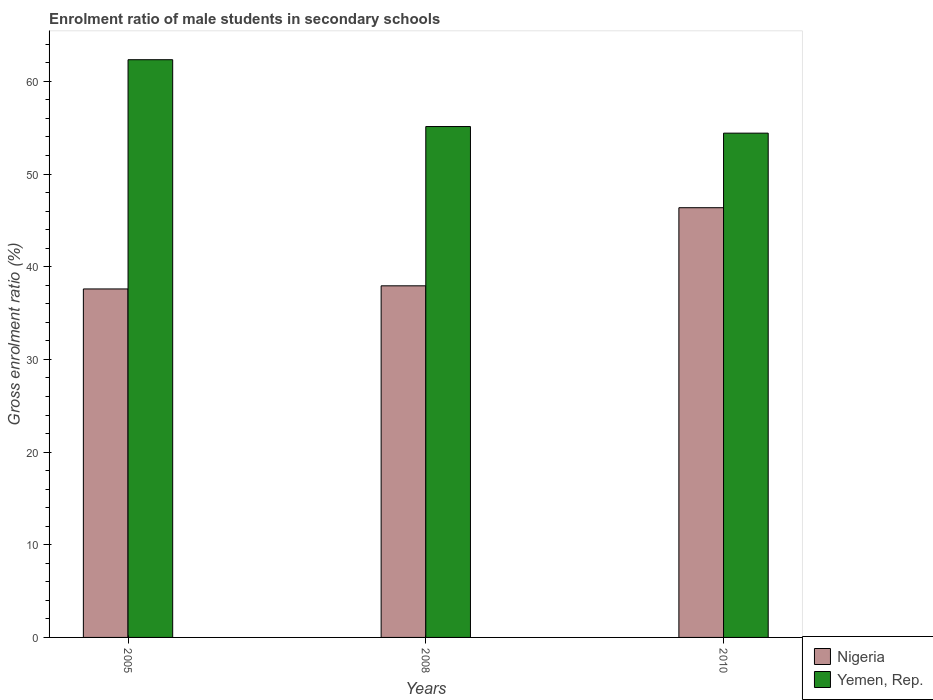How many groups of bars are there?
Provide a short and direct response. 3. Are the number of bars per tick equal to the number of legend labels?
Make the answer very short. Yes. What is the enrolment ratio of male students in secondary schools in Yemen, Rep. in 2008?
Your answer should be compact. 55.13. Across all years, what is the maximum enrolment ratio of male students in secondary schools in Yemen, Rep.?
Make the answer very short. 62.34. Across all years, what is the minimum enrolment ratio of male students in secondary schools in Nigeria?
Provide a succinct answer. 37.6. What is the total enrolment ratio of male students in secondary schools in Nigeria in the graph?
Your answer should be compact. 121.91. What is the difference between the enrolment ratio of male students in secondary schools in Yemen, Rep. in 2008 and that in 2010?
Provide a succinct answer. 0.71. What is the difference between the enrolment ratio of male students in secondary schools in Nigeria in 2008 and the enrolment ratio of male students in secondary schools in Yemen, Rep. in 2010?
Your answer should be compact. -16.47. What is the average enrolment ratio of male students in secondary schools in Nigeria per year?
Your answer should be compact. 40.64. In the year 2010, what is the difference between the enrolment ratio of male students in secondary schools in Yemen, Rep. and enrolment ratio of male students in secondary schools in Nigeria?
Your response must be concise. 8.05. In how many years, is the enrolment ratio of male students in secondary schools in Nigeria greater than 22 %?
Your answer should be compact. 3. What is the ratio of the enrolment ratio of male students in secondary schools in Yemen, Rep. in 2005 to that in 2010?
Make the answer very short. 1.15. What is the difference between the highest and the second highest enrolment ratio of male students in secondary schools in Nigeria?
Make the answer very short. 8.43. What is the difference between the highest and the lowest enrolment ratio of male students in secondary schools in Yemen, Rep.?
Make the answer very short. 7.92. In how many years, is the enrolment ratio of male students in secondary schools in Yemen, Rep. greater than the average enrolment ratio of male students in secondary schools in Yemen, Rep. taken over all years?
Give a very brief answer. 1. What does the 1st bar from the left in 2010 represents?
Make the answer very short. Nigeria. What does the 1st bar from the right in 2005 represents?
Ensure brevity in your answer.  Yemen, Rep. How many bars are there?
Offer a terse response. 6. What is the difference between two consecutive major ticks on the Y-axis?
Ensure brevity in your answer.  10. Are the values on the major ticks of Y-axis written in scientific E-notation?
Provide a short and direct response. No. Does the graph contain any zero values?
Your answer should be very brief. No. Does the graph contain grids?
Provide a short and direct response. No. What is the title of the graph?
Offer a terse response. Enrolment ratio of male students in secondary schools. What is the label or title of the X-axis?
Provide a short and direct response. Years. What is the Gross enrolment ratio (%) in Nigeria in 2005?
Offer a terse response. 37.6. What is the Gross enrolment ratio (%) in Yemen, Rep. in 2005?
Offer a very short reply. 62.34. What is the Gross enrolment ratio (%) in Nigeria in 2008?
Offer a very short reply. 37.94. What is the Gross enrolment ratio (%) of Yemen, Rep. in 2008?
Make the answer very short. 55.13. What is the Gross enrolment ratio (%) in Nigeria in 2010?
Keep it short and to the point. 46.37. What is the Gross enrolment ratio (%) in Yemen, Rep. in 2010?
Your answer should be very brief. 54.41. Across all years, what is the maximum Gross enrolment ratio (%) in Nigeria?
Your answer should be very brief. 46.37. Across all years, what is the maximum Gross enrolment ratio (%) of Yemen, Rep.?
Provide a succinct answer. 62.34. Across all years, what is the minimum Gross enrolment ratio (%) in Nigeria?
Give a very brief answer. 37.6. Across all years, what is the minimum Gross enrolment ratio (%) of Yemen, Rep.?
Your answer should be very brief. 54.41. What is the total Gross enrolment ratio (%) of Nigeria in the graph?
Offer a very short reply. 121.91. What is the total Gross enrolment ratio (%) in Yemen, Rep. in the graph?
Your answer should be very brief. 171.88. What is the difference between the Gross enrolment ratio (%) in Nigeria in 2005 and that in 2008?
Make the answer very short. -0.34. What is the difference between the Gross enrolment ratio (%) in Yemen, Rep. in 2005 and that in 2008?
Offer a very short reply. 7.21. What is the difference between the Gross enrolment ratio (%) of Nigeria in 2005 and that in 2010?
Provide a short and direct response. -8.77. What is the difference between the Gross enrolment ratio (%) of Yemen, Rep. in 2005 and that in 2010?
Offer a very short reply. 7.92. What is the difference between the Gross enrolment ratio (%) in Nigeria in 2008 and that in 2010?
Make the answer very short. -8.43. What is the difference between the Gross enrolment ratio (%) in Yemen, Rep. in 2008 and that in 2010?
Keep it short and to the point. 0.71. What is the difference between the Gross enrolment ratio (%) of Nigeria in 2005 and the Gross enrolment ratio (%) of Yemen, Rep. in 2008?
Provide a succinct answer. -17.52. What is the difference between the Gross enrolment ratio (%) of Nigeria in 2005 and the Gross enrolment ratio (%) of Yemen, Rep. in 2010?
Give a very brief answer. -16.81. What is the difference between the Gross enrolment ratio (%) in Nigeria in 2008 and the Gross enrolment ratio (%) in Yemen, Rep. in 2010?
Offer a terse response. -16.47. What is the average Gross enrolment ratio (%) of Nigeria per year?
Give a very brief answer. 40.64. What is the average Gross enrolment ratio (%) in Yemen, Rep. per year?
Offer a very short reply. 57.29. In the year 2005, what is the difference between the Gross enrolment ratio (%) in Nigeria and Gross enrolment ratio (%) in Yemen, Rep.?
Your answer should be very brief. -24.74. In the year 2008, what is the difference between the Gross enrolment ratio (%) of Nigeria and Gross enrolment ratio (%) of Yemen, Rep.?
Your answer should be compact. -17.19. In the year 2010, what is the difference between the Gross enrolment ratio (%) in Nigeria and Gross enrolment ratio (%) in Yemen, Rep.?
Offer a very short reply. -8.05. What is the ratio of the Gross enrolment ratio (%) of Nigeria in 2005 to that in 2008?
Provide a succinct answer. 0.99. What is the ratio of the Gross enrolment ratio (%) of Yemen, Rep. in 2005 to that in 2008?
Provide a short and direct response. 1.13. What is the ratio of the Gross enrolment ratio (%) in Nigeria in 2005 to that in 2010?
Ensure brevity in your answer.  0.81. What is the ratio of the Gross enrolment ratio (%) in Yemen, Rep. in 2005 to that in 2010?
Offer a terse response. 1.15. What is the ratio of the Gross enrolment ratio (%) of Nigeria in 2008 to that in 2010?
Provide a succinct answer. 0.82. What is the ratio of the Gross enrolment ratio (%) in Yemen, Rep. in 2008 to that in 2010?
Your response must be concise. 1.01. What is the difference between the highest and the second highest Gross enrolment ratio (%) in Nigeria?
Ensure brevity in your answer.  8.43. What is the difference between the highest and the second highest Gross enrolment ratio (%) of Yemen, Rep.?
Your response must be concise. 7.21. What is the difference between the highest and the lowest Gross enrolment ratio (%) of Nigeria?
Your answer should be compact. 8.77. What is the difference between the highest and the lowest Gross enrolment ratio (%) in Yemen, Rep.?
Give a very brief answer. 7.92. 